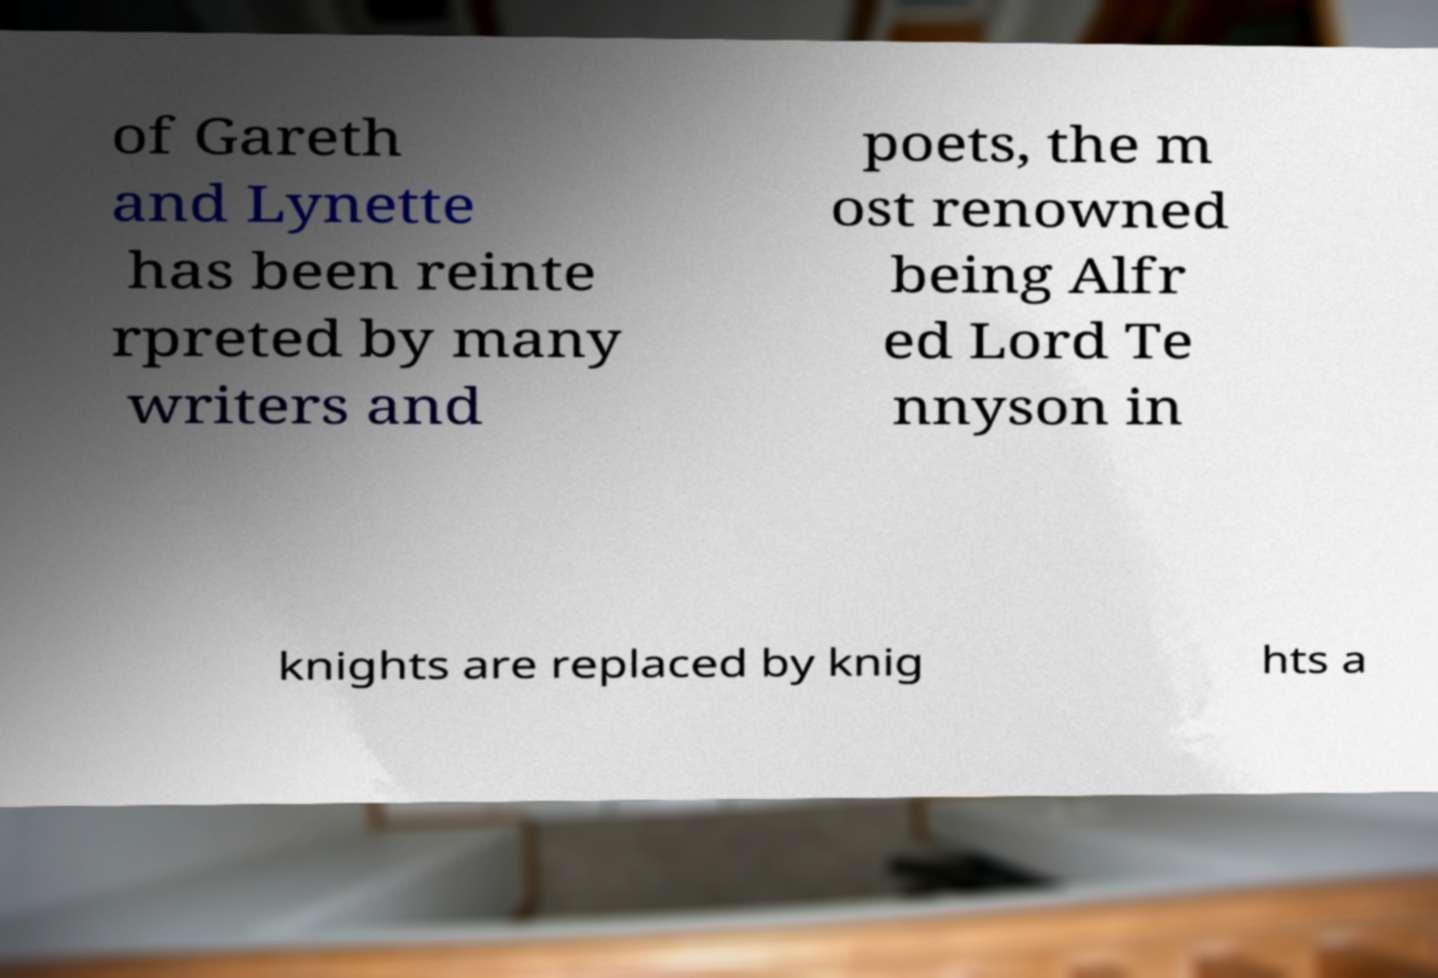Please read and relay the text visible in this image. What does it say? of Gareth and Lynette has been reinte rpreted by many writers and poets, the m ost renowned being Alfr ed Lord Te nnyson in knights are replaced by knig hts a 